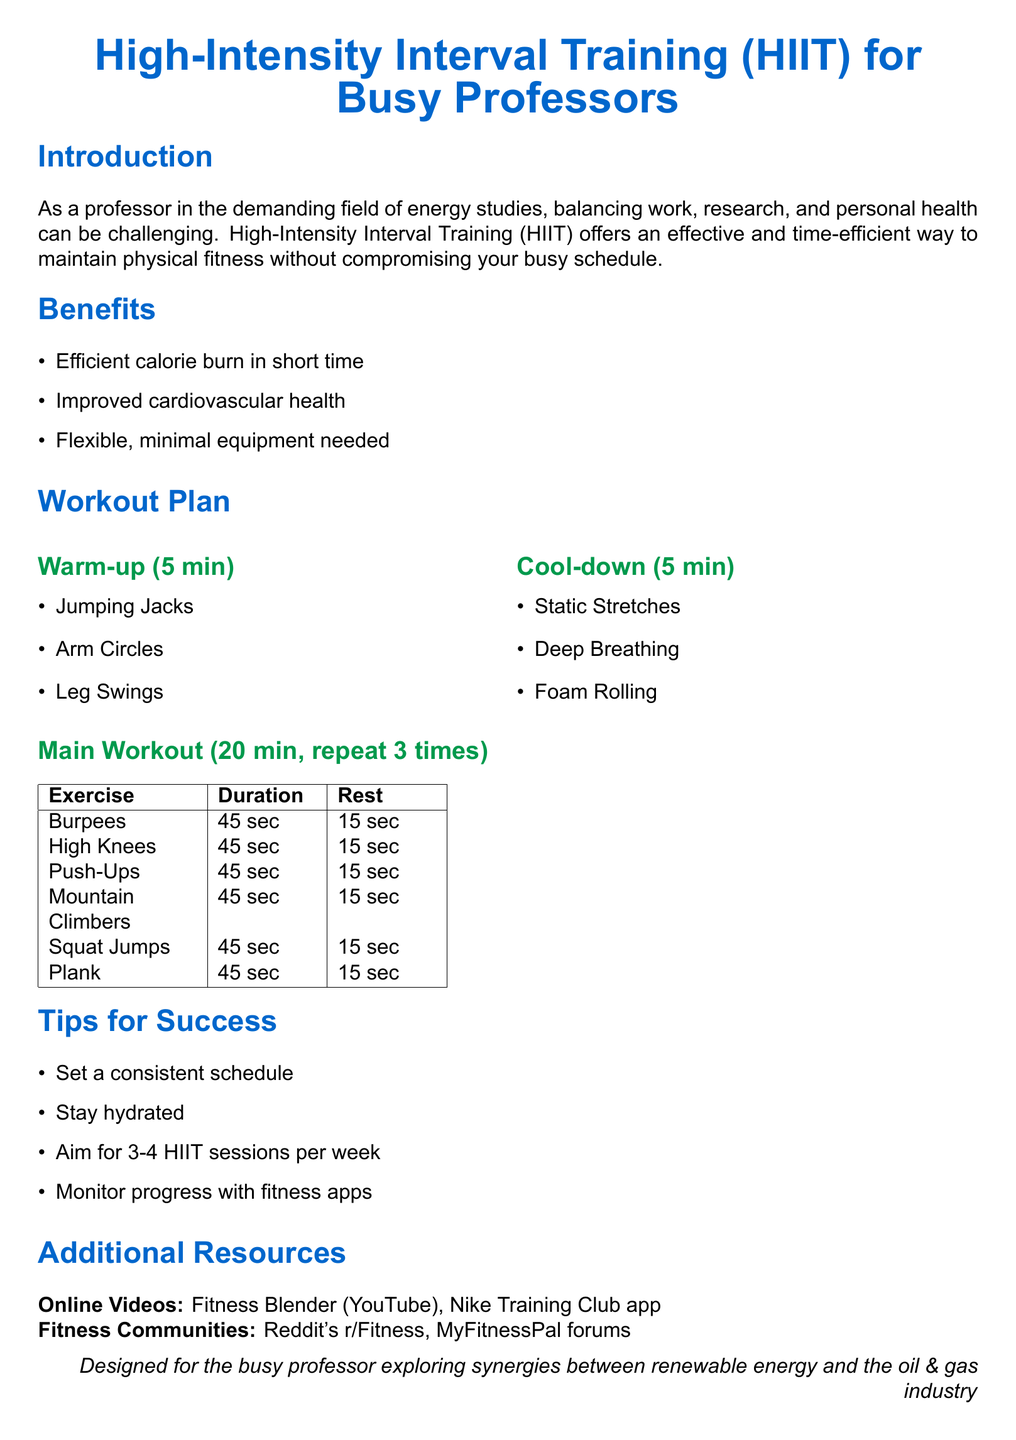What is the duration of the warm-up? The warm-up section specifies that it lasts for 5 minutes.
Answer: 5 min How many times should the main workout be repeated? The document states that the main workout should be repeated 3 times.
Answer: 3 times What exercise is performed for 45 seconds with a 15-second rest right after high knees? The exercise following high knees in the main workout is push-ups.
Answer: Push-Ups Which resource is mentioned as an online video for fitness? The document lists Fitness Blender as one of the online video resources.
Answer: Fitness Blender How many HIIT sessions per week does the plan suggest aiming for? The tips section recommends aiming for 3-4 HIIT sessions per week.
Answer: 3-4 What type of training does the document focus on? The document emphasizes High-Intensity Interval Training (HIIT).
Answer: HIIT What exercise involves jumping and squatting? The exercise that includes both jumping and squatting is squat jumps.
Answer: Squat Jumps What is one of the benefits of HIIT mentioned in the document? One of the benefits listed is improved cardiovascular health.
Answer: Improved cardiovascular health 